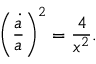Convert formula to latex. <formula><loc_0><loc_0><loc_500><loc_500>\left ( { \frac { \dot { a } } { a } } \right ) ^ { 2 } = { \frac { 4 } { x ^ { 2 } } } .</formula> 